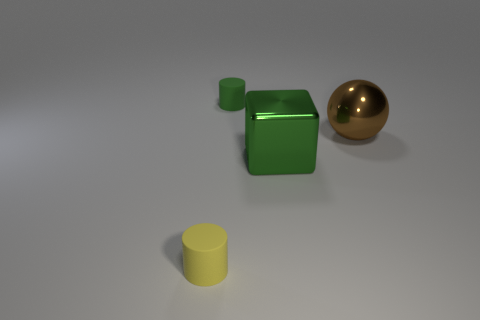What color is the thing that is both right of the small green rubber thing and behind the cube?
Offer a terse response. Brown. Is the small cylinder that is in front of the brown metallic object made of the same material as the green thing that is behind the metallic ball?
Make the answer very short. Yes. Does the matte object that is behind the brown shiny ball have the same size as the ball?
Offer a very short reply. No. There is a cube; is it the same color as the tiny thing behind the brown object?
Offer a very short reply. Yes. There is a small rubber thing that is the same color as the block; what is its shape?
Give a very brief answer. Cylinder. The tiny yellow thing is what shape?
Keep it short and to the point. Cylinder. How many things are either objects that are in front of the green matte object or tiny green rubber cylinders?
Give a very brief answer. 4. What size is the cube that is made of the same material as the large brown sphere?
Give a very brief answer. Large. Is the number of brown objects behind the yellow cylinder greater than the number of cyan matte balls?
Offer a very short reply. Yes. Is the shape of the tiny yellow rubber object the same as the rubber thing that is behind the big green block?
Offer a terse response. Yes. 